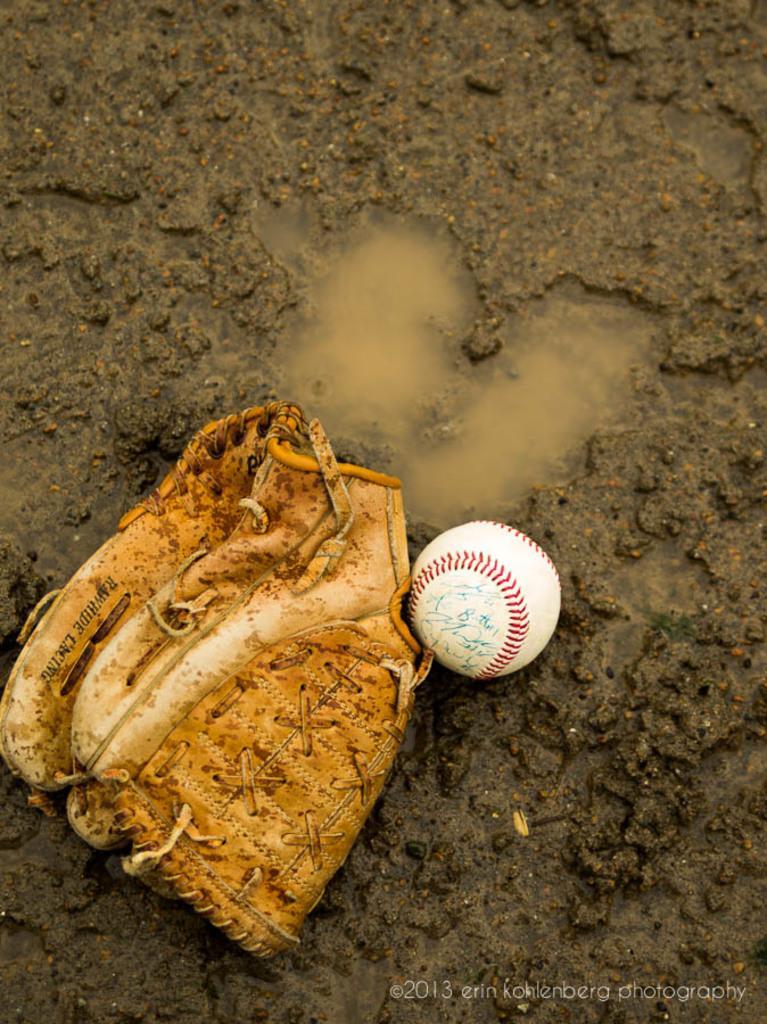Can you describe this image briefly? In this image I can see a brown colour glove, a white colour ball and water. 